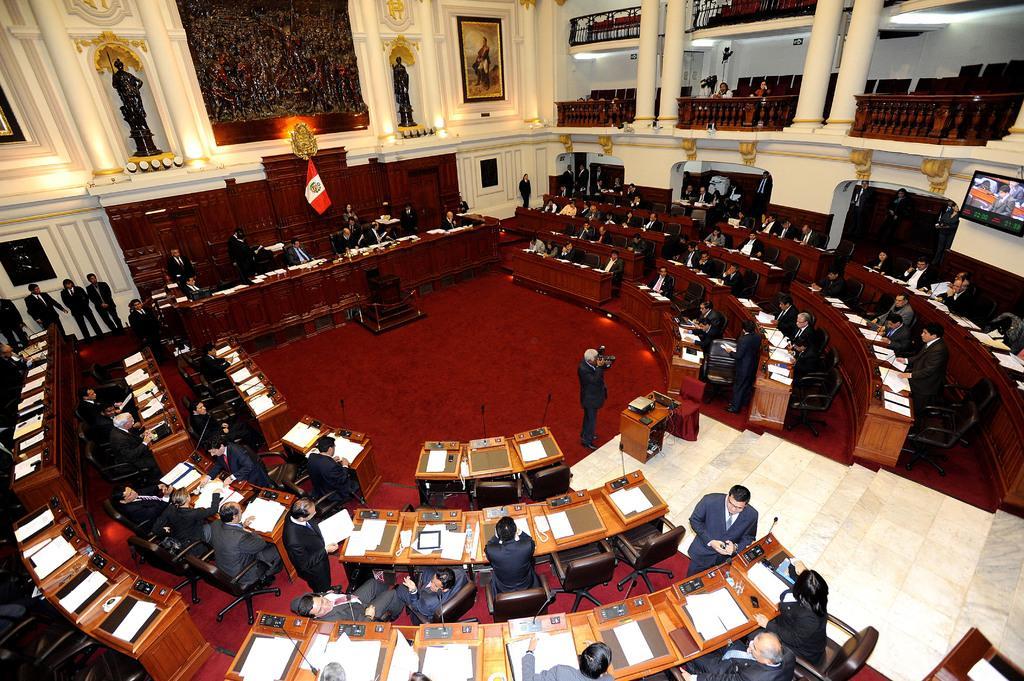In one or two sentences, can you explain what this image depicts? There are groups of people sitting on the chairs and few people standing. This is the flag hanging. These are the sculptures. I can see the photo frame attached to the wall. These are the pillars. I can see the tables with papers, files and mike's. This is the television screen, which is attached to the wall. I can see a person standing and holding a camera. This looks like a projector, which is placed on the table. I think this is the video recorder. 